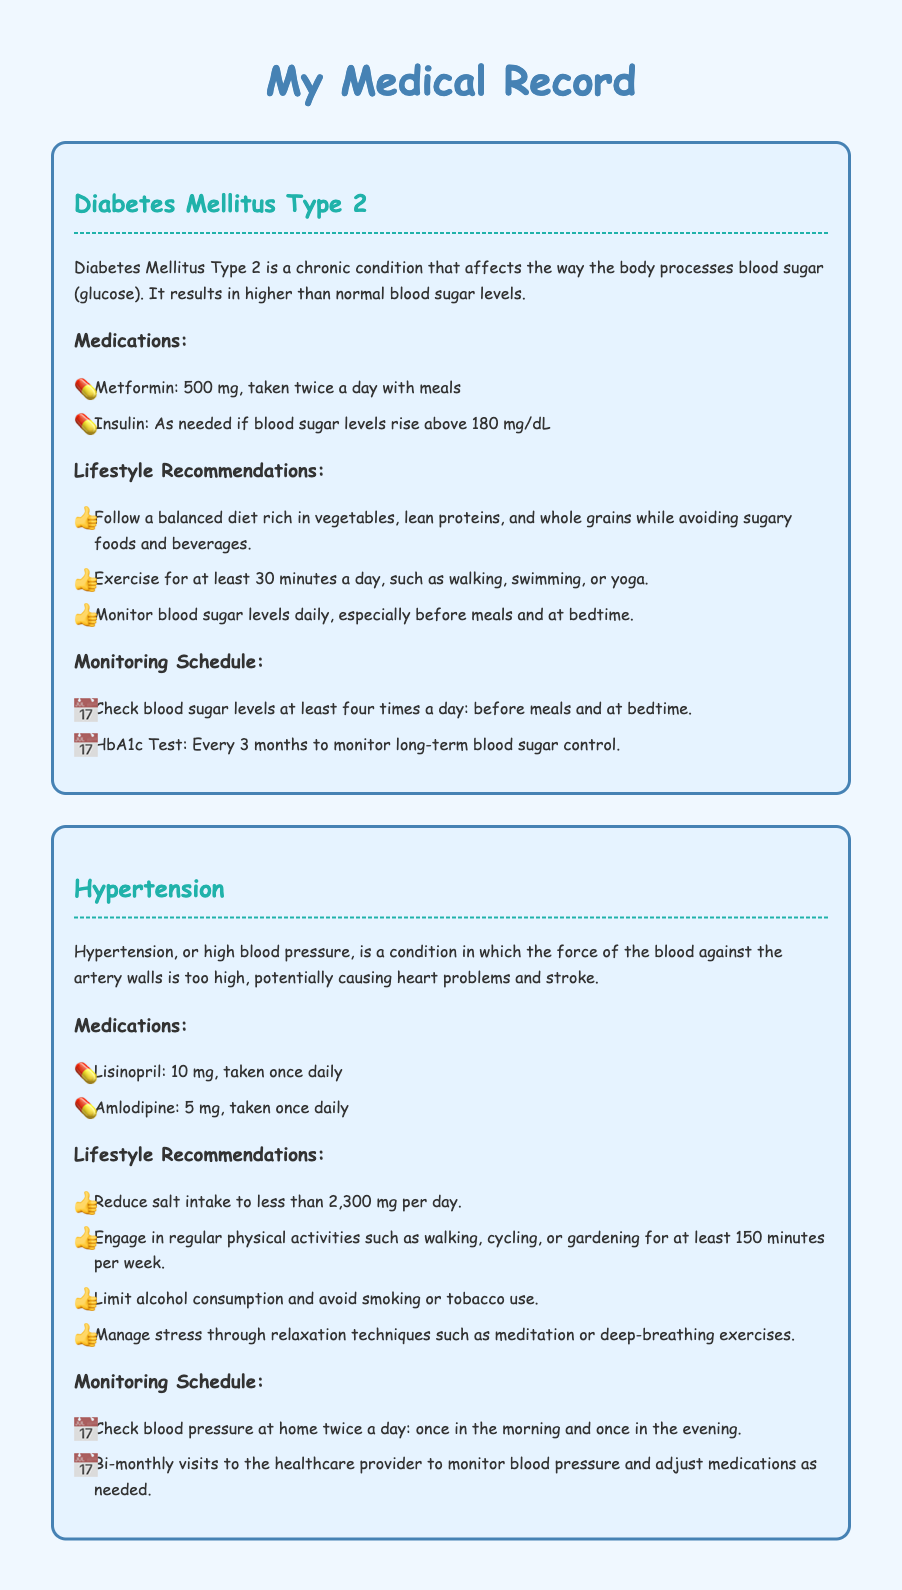What is the medication for diabetes? The document lists Metformin and Insulin as medications for diabetes.
Answer: Metformin, Insulin How often should blood pressure be checked? The document states that blood pressure should be checked at home twice a day.
Answer: Twice a day What is the dosage of Lisinopril? The document specifies the dosage of Lisinopril as 10 mg.
Answer: 10 mg What lifestyle change is recommended for hypertension? The document recommends reducing salt intake to less than 2,300 mg per day.
Answer: Reduce salt intake How often should the HbA1c test be done? The document advises that the HbA1c test should be done every 3 months.
Answer: Every 3 months What type of exercise is suggested for diabetes management? The document recommends exercising for at least 30 minutes a day through various activities.
Answer: At least 30 minutes What is a key lifestyle recommendation for managing hypertension? The document suggests managing stress through relaxation techniques such as meditation.
Answer: Manage stress What medication is taken as needed for diabetes? The document states that Insulin is taken as needed if blood sugar levels rise above 180 mg/dL.
Answer: Insulin 